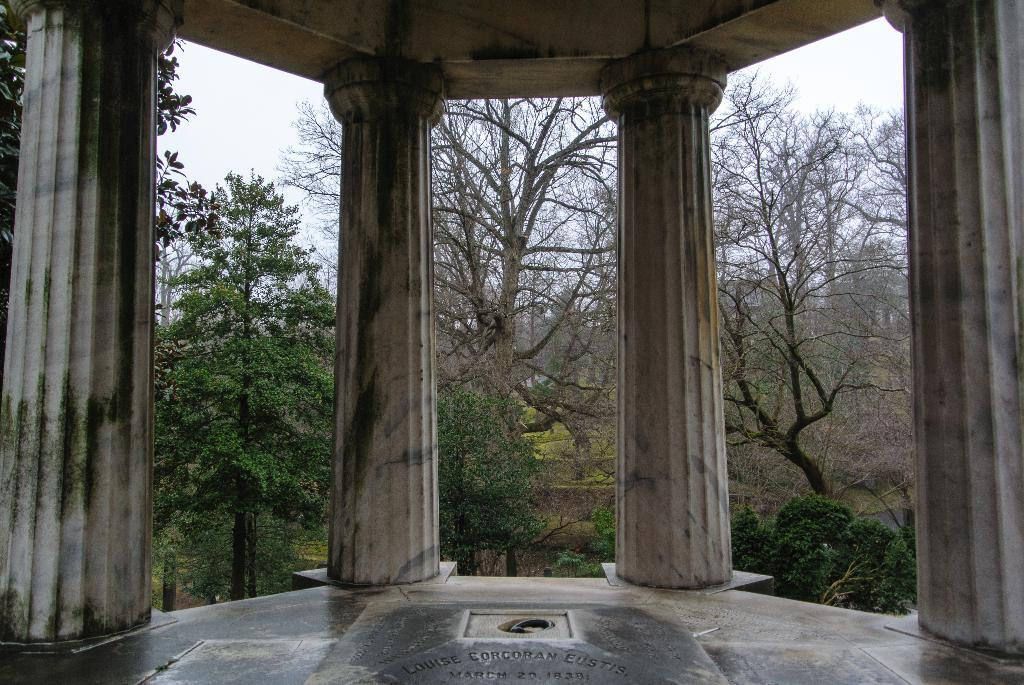What is the main structure visible in the foreground of the picture? There is a building in the foreground of the picture. What architectural feature can be seen on the building? There are pillars associated with the building. What can be seen in the background of the picture? There are trees in the background of the picture. How would you describe the sky in the image? The sky is cloudy. How many loaves of bread can be seen on the ground near the building? There is no bread visible in the image; it only features a building, pillars, trees, and a cloudy sky. 